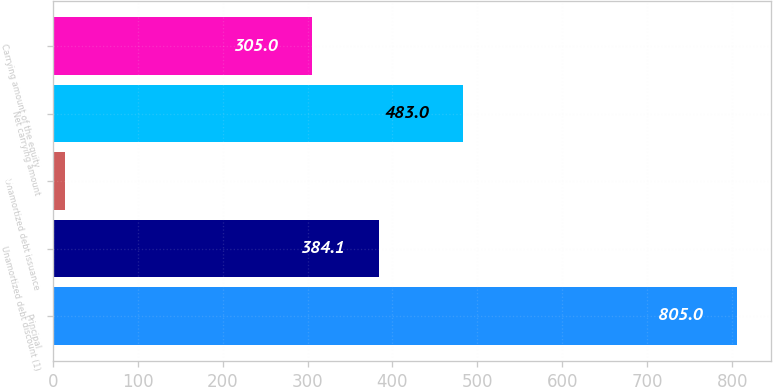Convert chart to OTSL. <chart><loc_0><loc_0><loc_500><loc_500><bar_chart><fcel>Principal<fcel>Unamortized debt discount (1)<fcel>Unamortized debt issuance<fcel>Net carrying amount<fcel>Carrying amount of the equity<nl><fcel>805<fcel>384.1<fcel>14<fcel>483<fcel>305<nl></chart> 